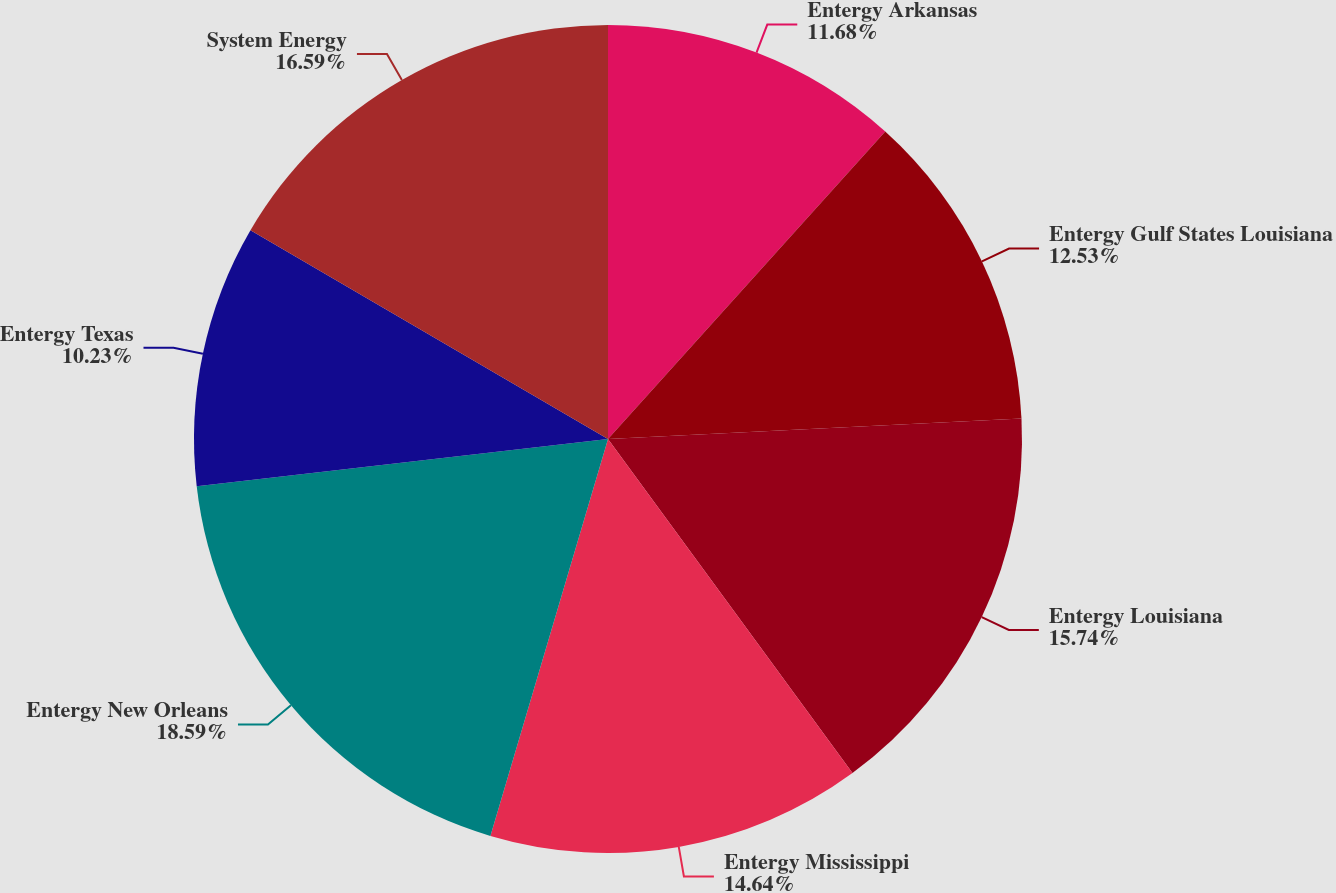Convert chart to OTSL. <chart><loc_0><loc_0><loc_500><loc_500><pie_chart><fcel>Entergy Arkansas<fcel>Entergy Gulf States Louisiana<fcel>Entergy Louisiana<fcel>Entergy Mississippi<fcel>Entergy New Orleans<fcel>Entergy Texas<fcel>System Energy<nl><fcel>11.68%<fcel>12.53%<fcel>15.74%<fcel>14.64%<fcel>18.6%<fcel>10.23%<fcel>16.59%<nl></chart> 